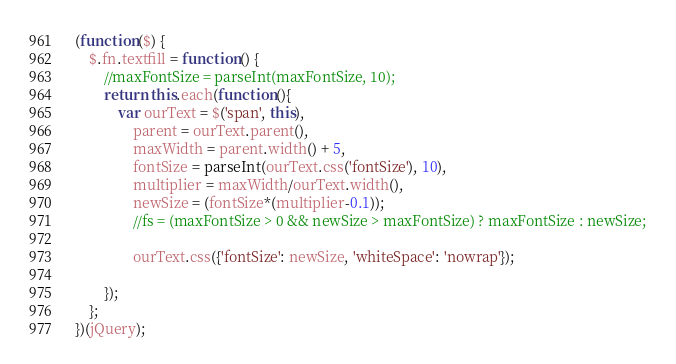<code> <loc_0><loc_0><loc_500><loc_500><_JavaScript_>(function($) {
    $.fn.textfill = function() {
        //maxFontSize = parseInt(maxFontSize, 10);
        return this.each(function(){
            var ourText = $('span', this),
                parent = ourText.parent(),
                maxWidth = parent.width() + 5,
                fontSize = parseInt(ourText.css('fontSize'), 10),
                multiplier = maxWidth/ourText.width(),
                newSize = (fontSize*(multiplier-0.1));
                //fs = (maxFontSize > 0 && newSize > maxFontSize) ? maxFontSize : newSize;
            	
            	ourText.css({'fontSize': newSize, 'whiteSpace': 'nowrap'});
            	
        });
    };
})(jQuery);</code> 